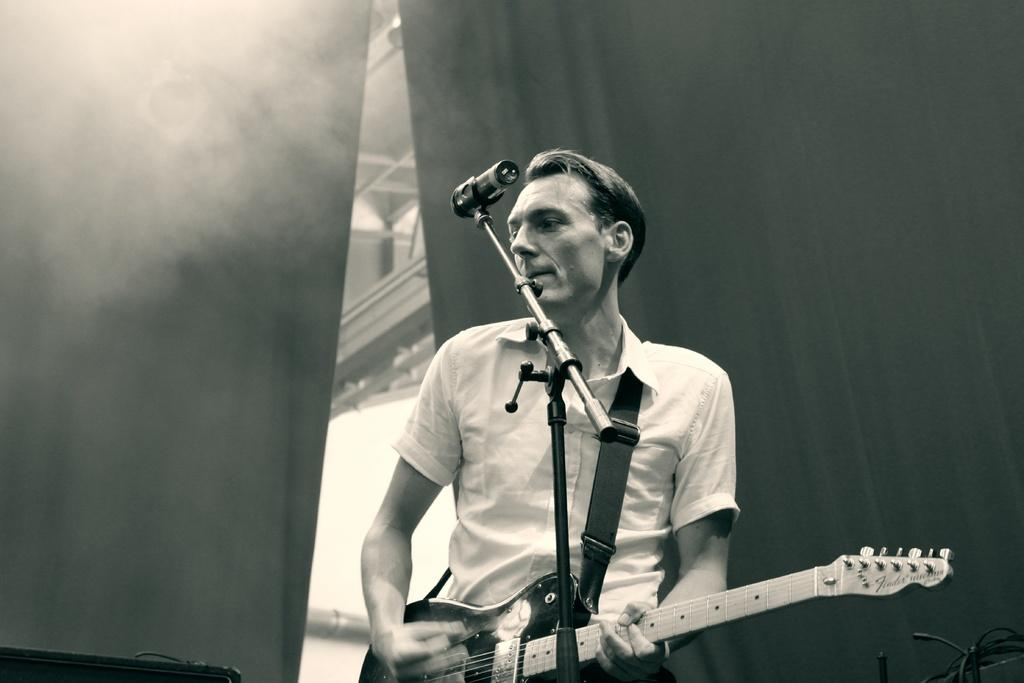Who is the main subject in the image? There is a man in the image. What is the man holding in the image? The man is holding a guitar. What object is the man standing in front of? The man is standing in front of a microphone. What type of ornament is hanging from the guitar in the image? There is no ornament hanging from the guitar in the image; the guitar is simply being held by the man. 